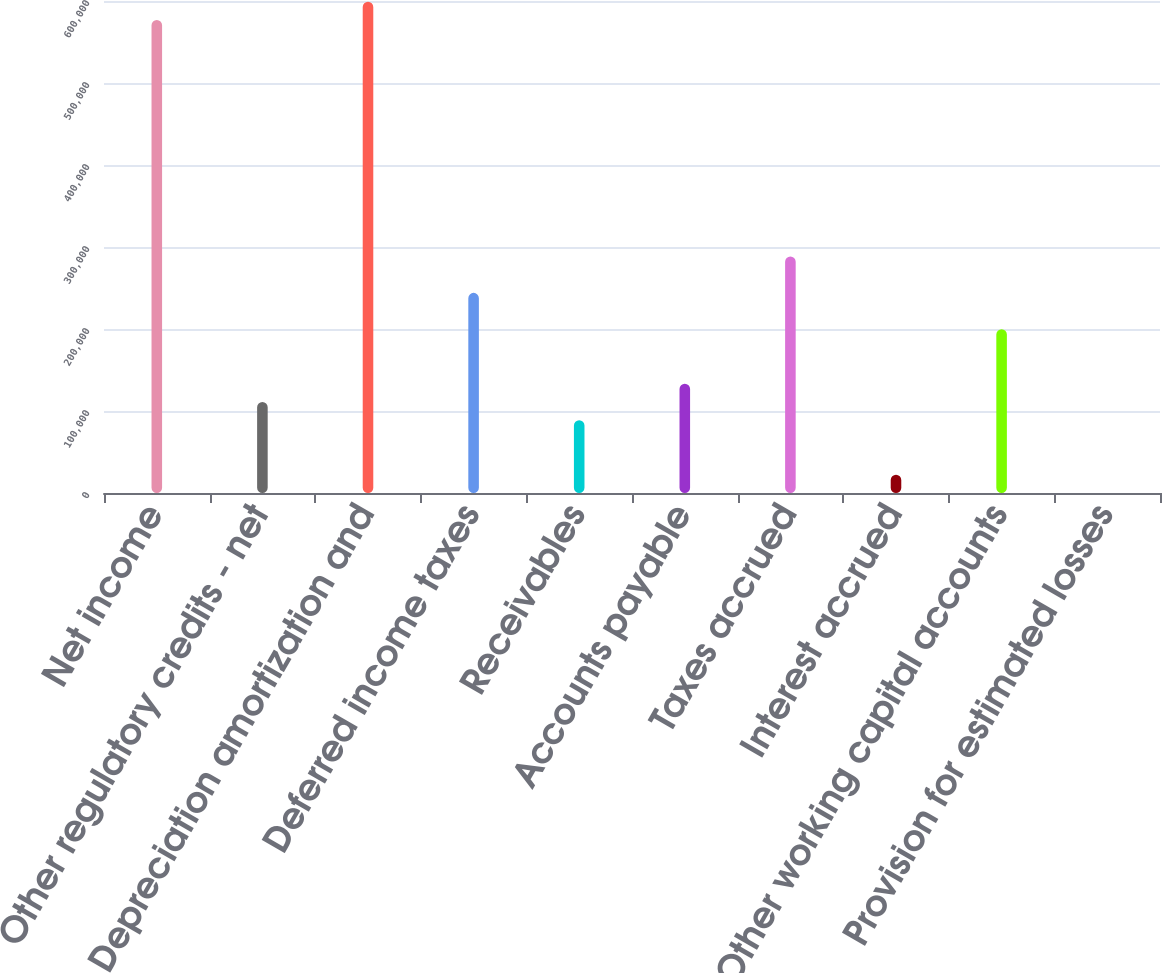Convert chart to OTSL. <chart><loc_0><loc_0><loc_500><loc_500><bar_chart><fcel>Net income<fcel>Other regulatory credits - net<fcel>Depreciation amortization and<fcel>Deferred income taxes<fcel>Receivables<fcel>Accounts payable<fcel>Taxes accrued<fcel>Interest accrued<fcel>Other working capital accounts<fcel>Provision for estimated losses<nl><fcel>576867<fcel>110974<fcel>599053<fcel>244086<fcel>88788.6<fcel>133159<fcel>288457<fcel>22232.4<fcel>199716<fcel>47<nl></chart> 